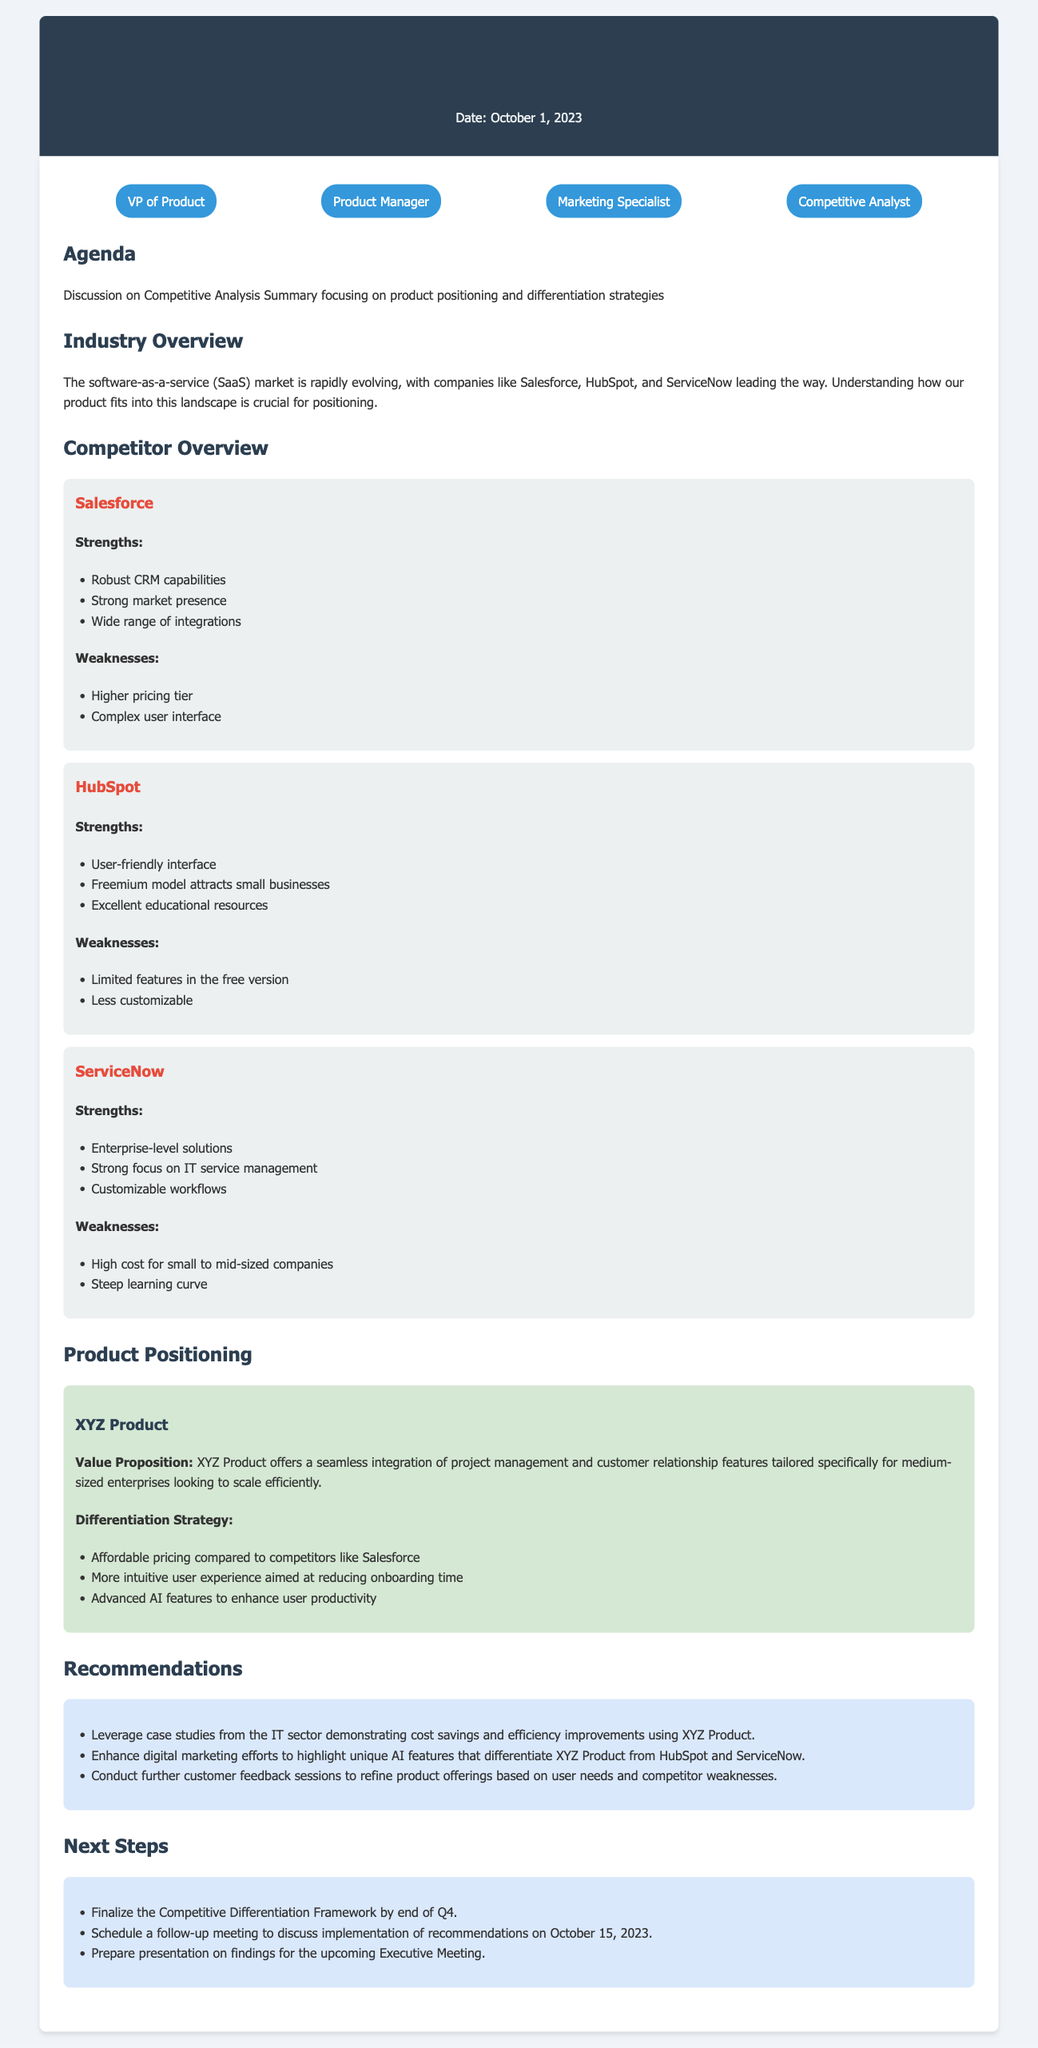What is the date of the meeting? The date of the meeting is stated in the header of the document.
Answer: October 1, 2023 Who is one of the attendees at the meeting? Attendees are listed in the "attendees" section of the document.
Answer: VP of Product What is the primary focus of the Competitive Analysis Summary? The focus is described in the "Agenda" section of the document.
Answer: product positioning and differentiation strategies Name a strength of Salesforce. Strengths of Salesforce are listed under its overview section.
Answer: Robust CRM capabilities What is the value proposition of XYZ Product? The value proposition is located in the "Product Positioning" section of the document.
Answer: seamless integration of project management and customer relationship features tailored specifically for medium-sized enterprises What recommendation is made regarding digital marketing? Recommendations are listed in the "Recommendations" section of the document.
Answer: Enhance digital marketing efforts to highlight unique AI features What is one of the next steps mentioned in the minutes? Next steps are outlined in the "Next Steps" section of the document.
Answer: Finalize the Competitive Differentiation Framework by end of Q4 How many competitors are discussed in the document? The competitors are listed in the "Competitor Overview" section of the document.
Answer: Three What differentiates XYZ Product from its competitors in terms of user experience? The differentiation strategy mentions user experience factors in the "Product Positioning" section.
Answer: More intuitive user experience aimed at reducing onboarding time 